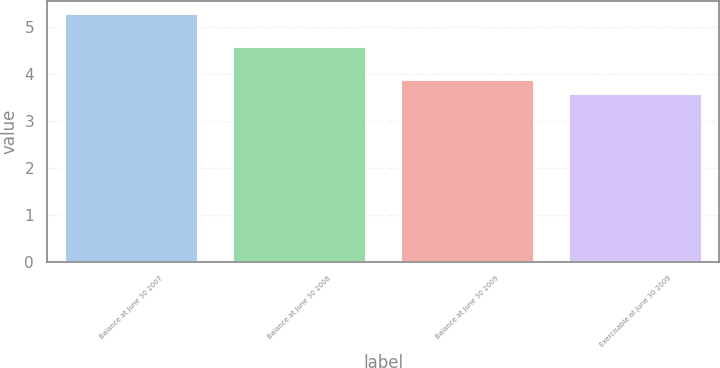Convert chart to OTSL. <chart><loc_0><loc_0><loc_500><loc_500><bar_chart><fcel>Balance at June 30 2007<fcel>Balance at June 30 2008<fcel>Balance at June 30 2009<fcel>Exercisable at June 30 2009<nl><fcel>5.3<fcel>4.6<fcel>3.9<fcel>3.6<nl></chart> 